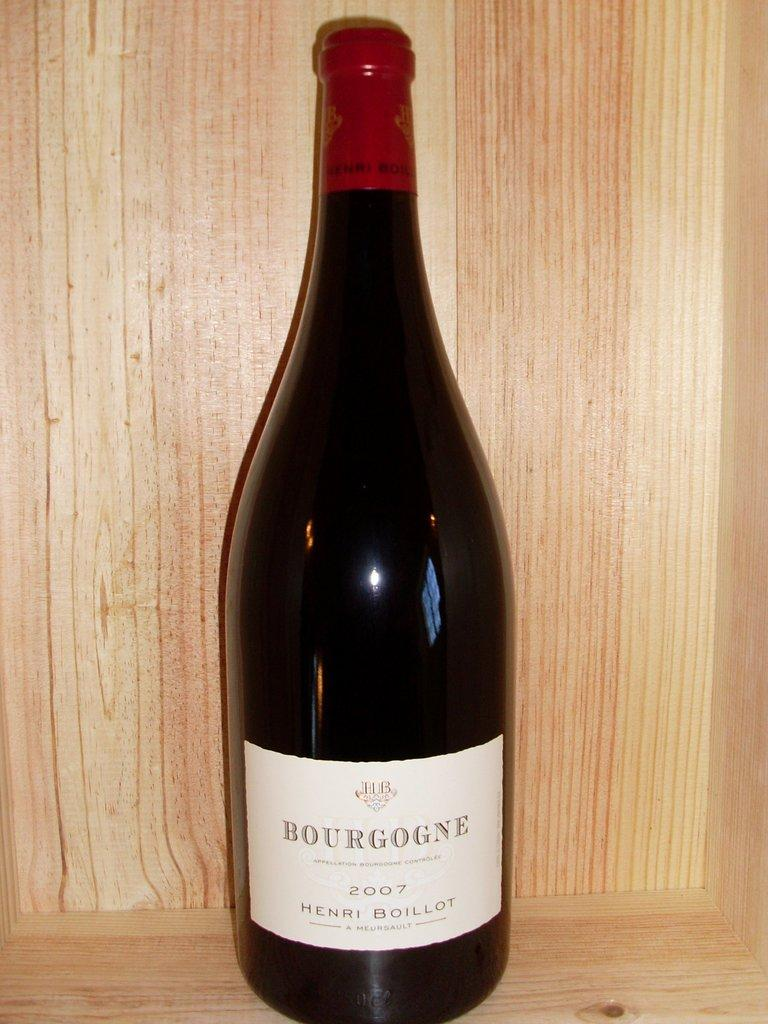<image>
Write a terse but informative summary of the picture. A bottle of  2007 Bourgogne sitting on a shelf. 